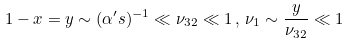Convert formula to latex. <formula><loc_0><loc_0><loc_500><loc_500>1 - x = y \sim ( \alpha ^ { \prime } s ) ^ { - 1 } \ll \nu _ { 3 2 } \ll 1 \, , \, \nu _ { 1 } \sim \frac { y } { \nu _ { 3 2 } } \ll 1</formula> 